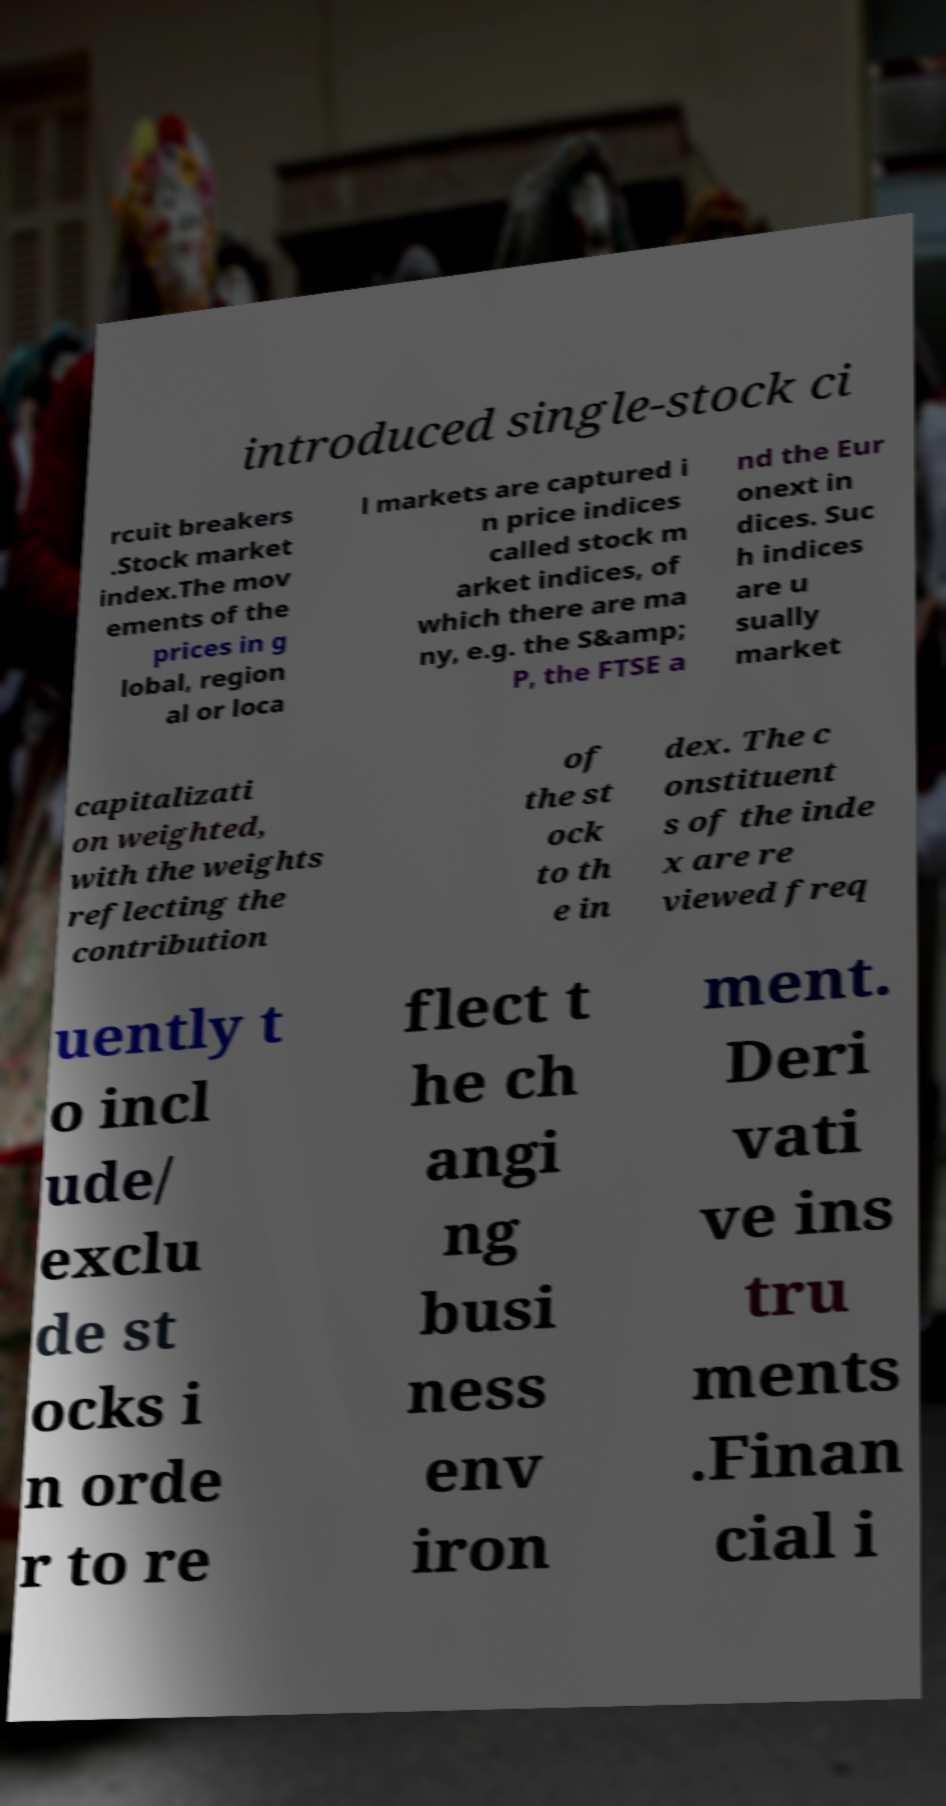Could you assist in decoding the text presented in this image and type it out clearly? introduced single-stock ci rcuit breakers .Stock market index.The mov ements of the prices in g lobal, region al or loca l markets are captured i n price indices called stock m arket indices, of which there are ma ny, e.g. the S&amp; P, the FTSE a nd the Eur onext in dices. Suc h indices are u sually market capitalizati on weighted, with the weights reflecting the contribution of the st ock to th e in dex. The c onstituent s of the inde x are re viewed freq uently t o incl ude/ exclu de st ocks i n orde r to re flect t he ch angi ng busi ness env iron ment. Deri vati ve ins tru ments .Finan cial i 